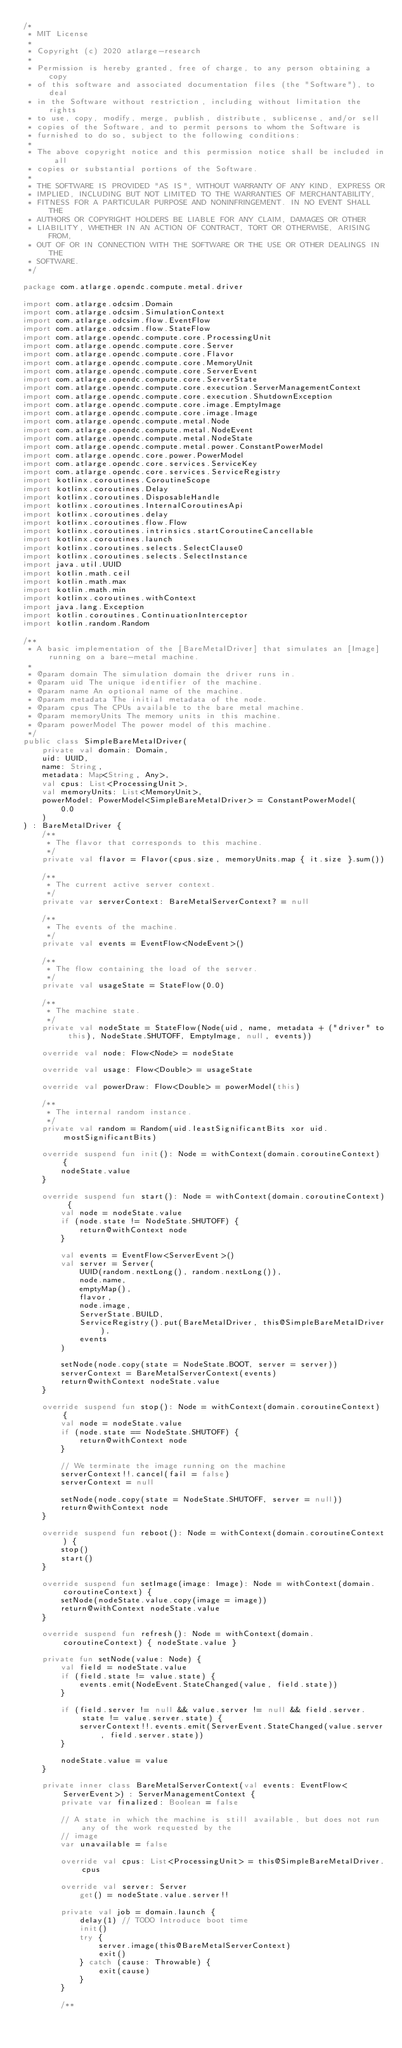<code> <loc_0><loc_0><loc_500><loc_500><_Kotlin_>/*
 * MIT License
 *
 * Copyright (c) 2020 atlarge-research
 *
 * Permission is hereby granted, free of charge, to any person obtaining a copy
 * of this software and associated documentation files (the "Software"), to deal
 * in the Software without restriction, including without limitation the rights
 * to use, copy, modify, merge, publish, distribute, sublicense, and/or sell
 * copies of the Software, and to permit persons to whom the Software is
 * furnished to do so, subject to the following conditions:
 *
 * The above copyright notice and this permission notice shall be included in all
 * copies or substantial portions of the Software.
 *
 * THE SOFTWARE IS PROVIDED "AS IS", WITHOUT WARRANTY OF ANY KIND, EXPRESS OR
 * IMPLIED, INCLUDING BUT NOT LIMITED TO THE WARRANTIES OF MERCHANTABILITY,
 * FITNESS FOR A PARTICULAR PURPOSE AND NONINFRINGEMENT. IN NO EVENT SHALL THE
 * AUTHORS OR COPYRIGHT HOLDERS BE LIABLE FOR ANY CLAIM, DAMAGES OR OTHER
 * LIABILITY, WHETHER IN AN ACTION OF CONTRACT, TORT OR OTHERWISE, ARISING FROM,
 * OUT OF OR IN CONNECTION WITH THE SOFTWARE OR THE USE OR OTHER DEALINGS IN THE
 * SOFTWARE.
 */

package com.atlarge.opendc.compute.metal.driver

import com.atlarge.odcsim.Domain
import com.atlarge.odcsim.SimulationContext
import com.atlarge.odcsim.flow.EventFlow
import com.atlarge.odcsim.flow.StateFlow
import com.atlarge.opendc.compute.core.ProcessingUnit
import com.atlarge.opendc.compute.core.Server
import com.atlarge.opendc.compute.core.Flavor
import com.atlarge.opendc.compute.core.MemoryUnit
import com.atlarge.opendc.compute.core.ServerEvent
import com.atlarge.opendc.compute.core.ServerState
import com.atlarge.opendc.compute.core.execution.ServerManagementContext
import com.atlarge.opendc.compute.core.execution.ShutdownException
import com.atlarge.opendc.compute.core.image.EmptyImage
import com.atlarge.opendc.compute.core.image.Image
import com.atlarge.opendc.compute.metal.Node
import com.atlarge.opendc.compute.metal.NodeEvent
import com.atlarge.opendc.compute.metal.NodeState
import com.atlarge.opendc.compute.metal.power.ConstantPowerModel
import com.atlarge.opendc.core.power.PowerModel
import com.atlarge.opendc.core.services.ServiceKey
import com.atlarge.opendc.core.services.ServiceRegistry
import kotlinx.coroutines.CoroutineScope
import kotlinx.coroutines.Delay
import kotlinx.coroutines.DisposableHandle
import kotlinx.coroutines.InternalCoroutinesApi
import kotlinx.coroutines.delay
import kotlinx.coroutines.flow.Flow
import kotlinx.coroutines.intrinsics.startCoroutineCancellable
import kotlinx.coroutines.launch
import kotlinx.coroutines.selects.SelectClause0
import kotlinx.coroutines.selects.SelectInstance
import java.util.UUID
import kotlin.math.ceil
import kotlin.math.max
import kotlin.math.min
import kotlinx.coroutines.withContext
import java.lang.Exception
import kotlin.coroutines.ContinuationInterceptor
import kotlin.random.Random

/**
 * A basic implementation of the [BareMetalDriver] that simulates an [Image] running on a bare-metal machine.
 *
 * @param domain The simulation domain the driver runs in.
 * @param uid The unique identifier of the machine.
 * @param name An optional name of the machine.
 * @param metadata The initial metadata of the node.
 * @param cpus The CPUs available to the bare metal machine.
 * @param memoryUnits The memory units in this machine.
 * @param powerModel The power model of this machine.
 */
public class SimpleBareMetalDriver(
    private val domain: Domain,
    uid: UUID,
    name: String,
    metadata: Map<String, Any>,
    val cpus: List<ProcessingUnit>,
    val memoryUnits: List<MemoryUnit>,
    powerModel: PowerModel<SimpleBareMetalDriver> = ConstantPowerModel(
        0.0
    )
) : BareMetalDriver {
    /**
     * The flavor that corresponds to this machine.
     */
    private val flavor = Flavor(cpus.size, memoryUnits.map { it.size }.sum())

    /**
     * The current active server context.
     */
    private var serverContext: BareMetalServerContext? = null

    /**
     * The events of the machine.
     */
    private val events = EventFlow<NodeEvent>()

    /**
     * The flow containing the load of the server.
     */
    private val usageState = StateFlow(0.0)

    /**
     * The machine state.
     */
    private val nodeState = StateFlow(Node(uid, name, metadata + ("driver" to this), NodeState.SHUTOFF, EmptyImage, null, events))

    override val node: Flow<Node> = nodeState

    override val usage: Flow<Double> = usageState

    override val powerDraw: Flow<Double> = powerModel(this)

    /**
     * The internal random instance.
     */
    private val random = Random(uid.leastSignificantBits xor uid.mostSignificantBits)

    override suspend fun init(): Node = withContext(domain.coroutineContext) {
        nodeState.value
    }

    override suspend fun start(): Node = withContext(domain.coroutineContext) {
        val node = nodeState.value
        if (node.state != NodeState.SHUTOFF) {
            return@withContext node
        }

        val events = EventFlow<ServerEvent>()
        val server = Server(
            UUID(random.nextLong(), random.nextLong()),
            node.name,
            emptyMap(),
            flavor,
            node.image,
            ServerState.BUILD,
            ServiceRegistry().put(BareMetalDriver, this@SimpleBareMetalDriver),
            events
        )

        setNode(node.copy(state = NodeState.BOOT, server = server))
        serverContext = BareMetalServerContext(events)
        return@withContext nodeState.value
    }

    override suspend fun stop(): Node = withContext(domain.coroutineContext) {
        val node = nodeState.value
        if (node.state == NodeState.SHUTOFF) {
            return@withContext node
        }

        // We terminate the image running on the machine
        serverContext!!.cancel(fail = false)
        serverContext = null

        setNode(node.copy(state = NodeState.SHUTOFF, server = null))
        return@withContext node
    }

    override suspend fun reboot(): Node = withContext(domain.coroutineContext) {
        stop()
        start()
    }

    override suspend fun setImage(image: Image): Node = withContext(domain.coroutineContext) {
        setNode(nodeState.value.copy(image = image))
        return@withContext nodeState.value
    }

    override suspend fun refresh(): Node = withContext(domain.coroutineContext) { nodeState.value }

    private fun setNode(value: Node) {
        val field = nodeState.value
        if (field.state != value.state) {
            events.emit(NodeEvent.StateChanged(value, field.state))
        }

        if (field.server != null && value.server != null && field.server.state != value.server.state) {
            serverContext!!.events.emit(ServerEvent.StateChanged(value.server, field.server.state))
        }

        nodeState.value = value
    }

    private inner class BareMetalServerContext(val events: EventFlow<ServerEvent>) : ServerManagementContext {
        private var finalized: Boolean = false

        // A state in which the machine is still available, but does not run any of the work requested by the
        // image
        var unavailable = false

        override val cpus: List<ProcessingUnit> = this@SimpleBareMetalDriver.cpus

        override val server: Server
            get() = nodeState.value.server!!

        private val job = domain.launch {
            delay(1) // TODO Introduce boot time
            init()
            try {
                server.image(this@BareMetalServerContext)
                exit()
            } catch (cause: Throwable) {
                exit(cause)
            }
        }

        /**</code> 